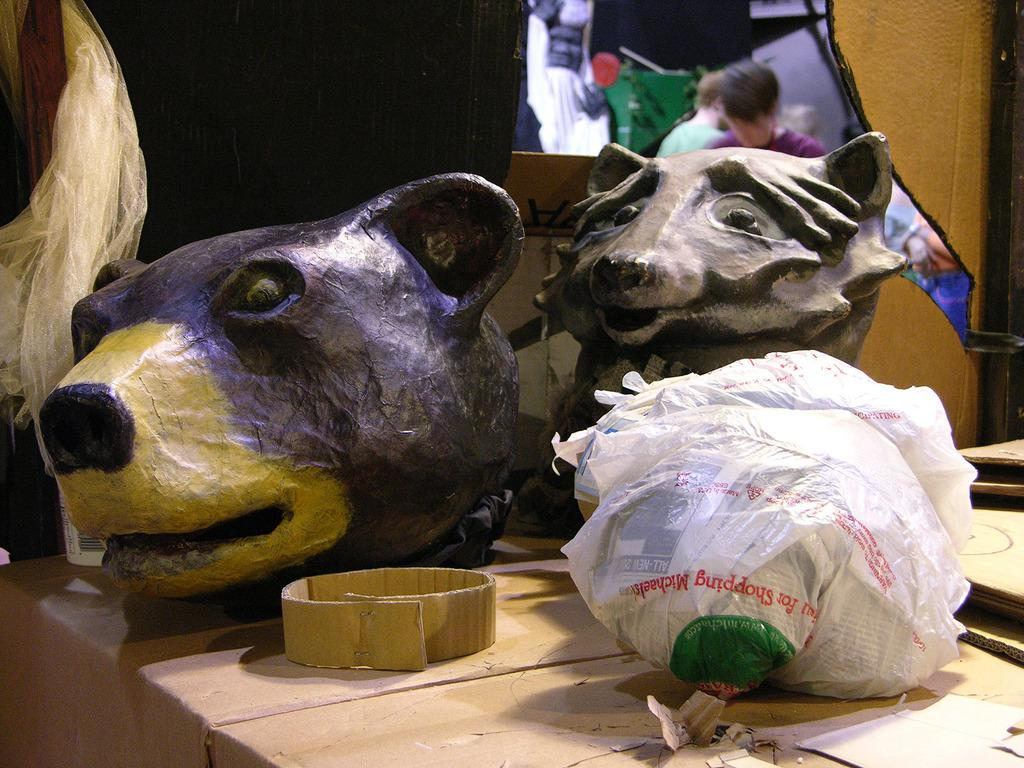What is on the table in the image? There are depictions of animals on a table in the image. Can you describe the people in the background of the image? There are persons visible in the background of the image. What shape is the brain of the father in the image? There is no brain or father present in the image; it only features depictions of animals on a table and persons in the background. 